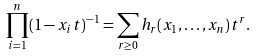<formula> <loc_0><loc_0><loc_500><loc_500>\prod _ { i = 1 } ^ { n } ( 1 - x _ { i } t ) ^ { - 1 } = \sum _ { r \geq 0 } h _ { r } ( x _ { 1 } , \dots , x _ { n } ) t ^ { r } .</formula> 